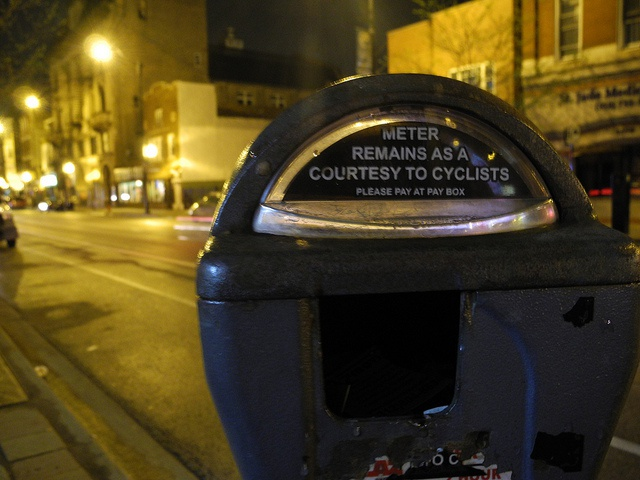Describe the objects in this image and their specific colors. I can see parking meter in black, gray, olive, and navy tones, car in black and olive tones, car in black, olive, and tan tones, car in black and olive tones, and car in black, maroon, olive, and gray tones in this image. 